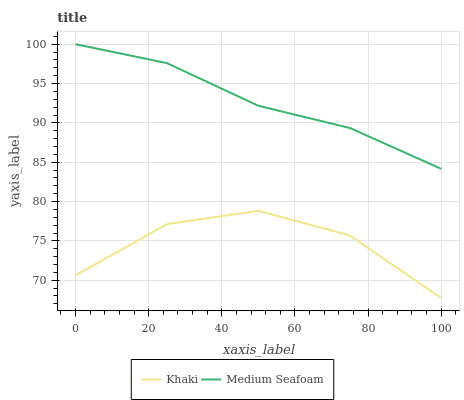Does Medium Seafoam have the minimum area under the curve?
Answer yes or no. No. Is Medium Seafoam the roughest?
Answer yes or no. No. Does Medium Seafoam have the lowest value?
Answer yes or no. No. Is Khaki less than Medium Seafoam?
Answer yes or no. Yes. Is Medium Seafoam greater than Khaki?
Answer yes or no. Yes. Does Khaki intersect Medium Seafoam?
Answer yes or no. No. 